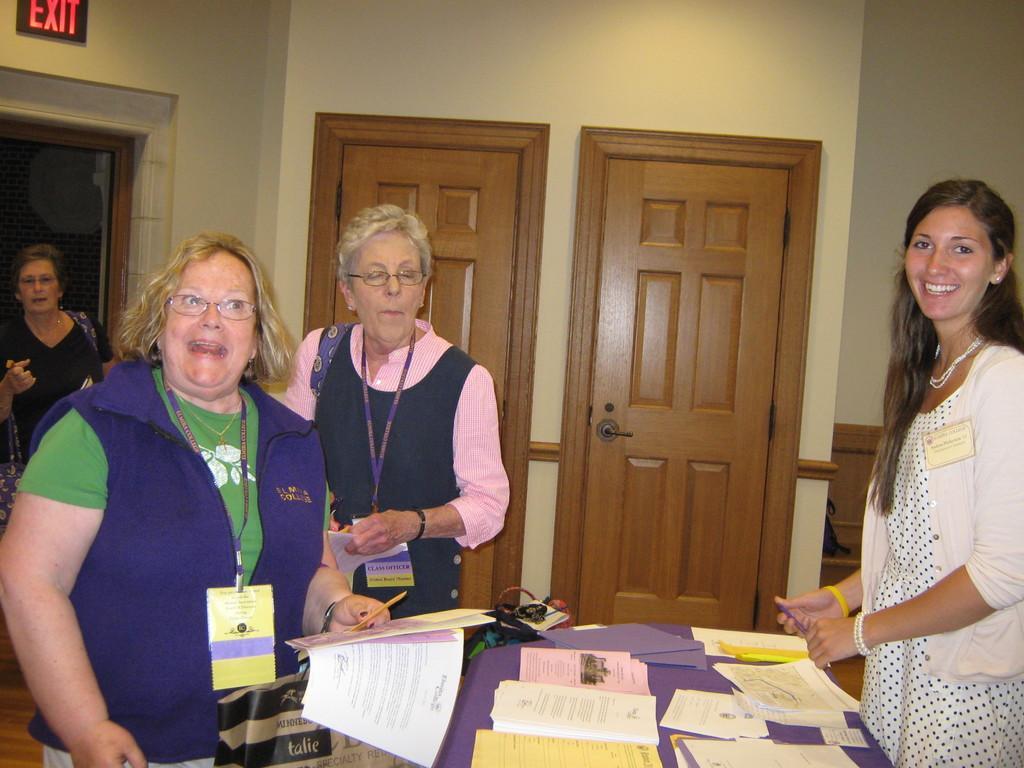How would you summarize this image in a sentence or two? In this image we can see some group of lady persons standing near the table on which there are some papers, books and two persons wearing ID cards holding some papers in their hands and in the background of the image there is a wall and doors. 